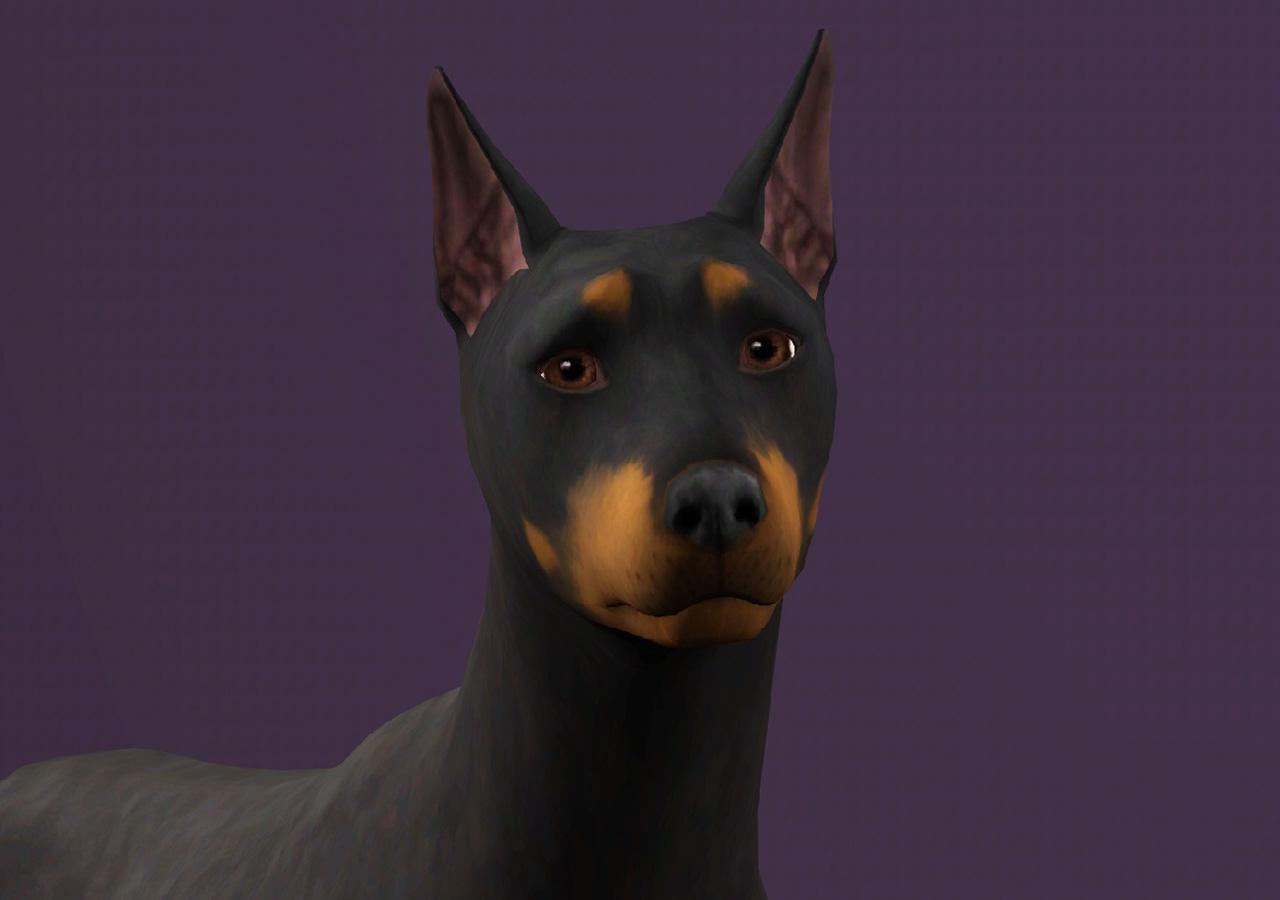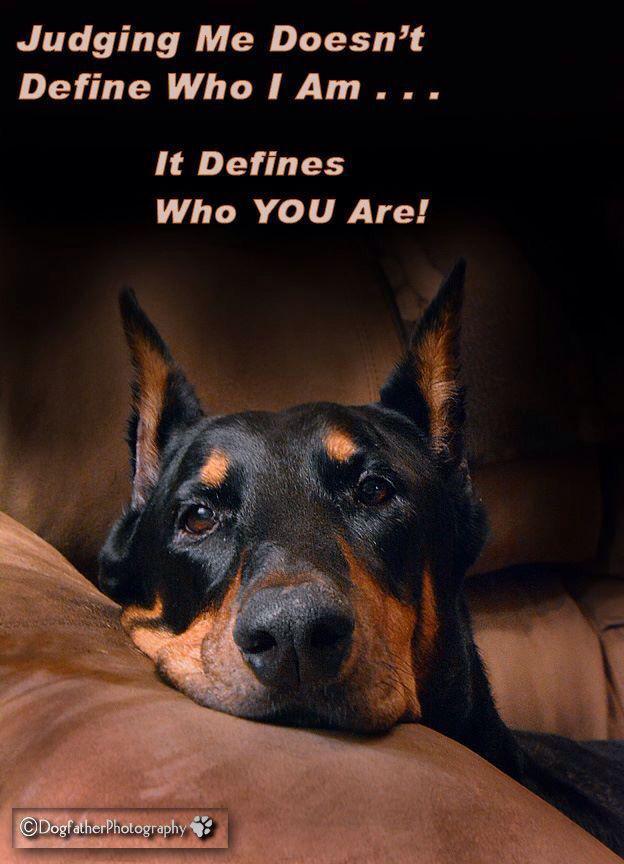The first image is the image on the left, the second image is the image on the right. Evaluate the accuracy of this statement regarding the images: "The doberman on the left has upright ears and wears a collar, and the doberman on the right has floppy ears and no collar.". Is it true? Answer yes or no. No. The first image is the image on the left, the second image is the image on the right. Examine the images to the left and right. Is the description "The dog in the image on the left is wearing a collar." accurate? Answer yes or no. No. 